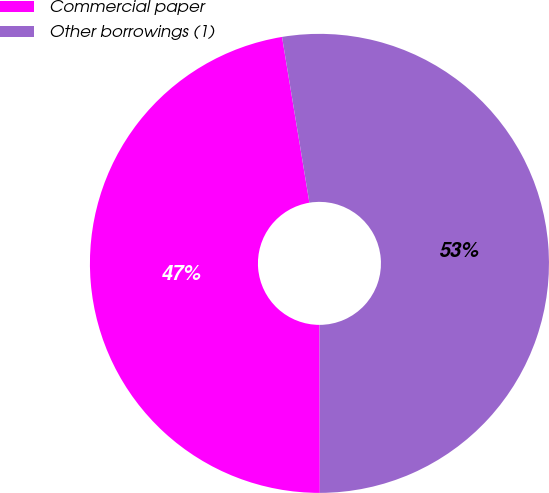Convert chart to OTSL. <chart><loc_0><loc_0><loc_500><loc_500><pie_chart><fcel>Commercial paper<fcel>Other borrowings (1)<nl><fcel>47.42%<fcel>52.58%<nl></chart> 